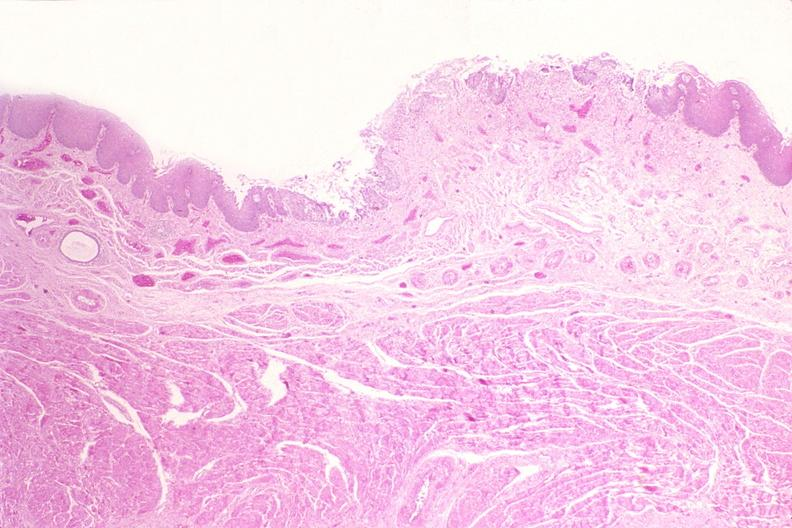s gastrointestinal present?
Answer the question using a single word or phrase. Yes 